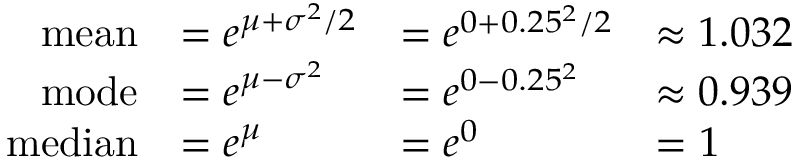<formula> <loc_0><loc_0><loc_500><loc_500>{ \begin{array} { r l l l } { m e a n } & { = e ^ { \mu + \sigma ^ { 2 } / 2 } } & { = e ^ { 0 + 0 . 2 5 ^ { 2 } / 2 } } & { \approx 1 . 0 3 2 } \\ { m o d e } & { = e ^ { \mu - \sigma ^ { 2 } } } & { = e ^ { 0 - 0 . 2 5 ^ { 2 } } } & { \approx 0 . 9 3 9 } \\ { m e d i a n } & { = e ^ { \mu } } & { = e ^ { 0 } } & { = 1 } \end{array} }</formula> 